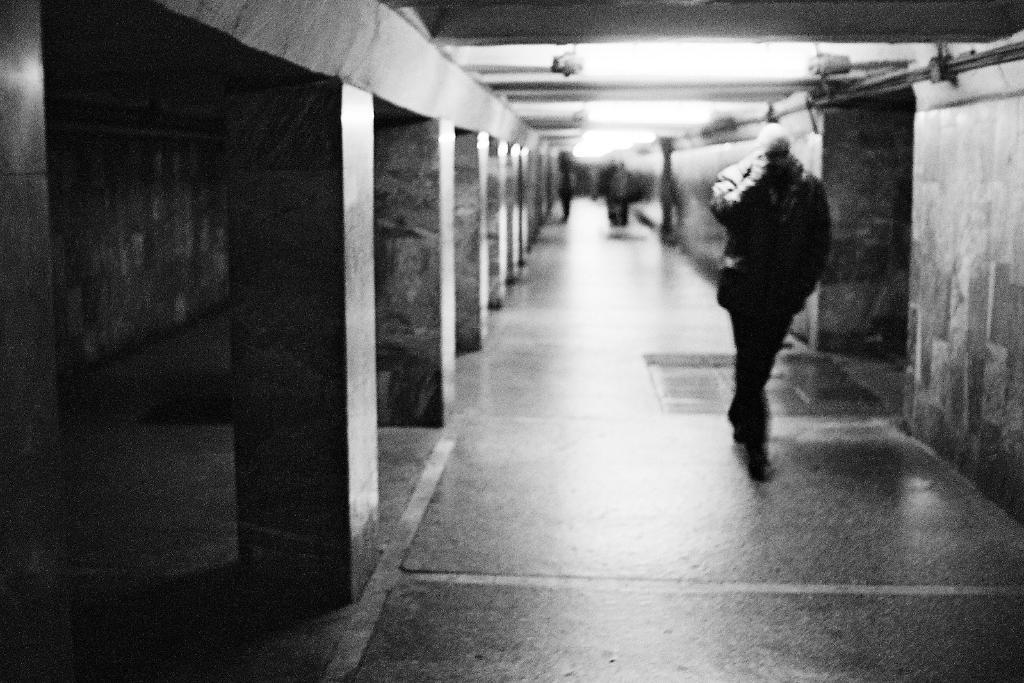Who or what can be seen in the image? There are people in the image. What architectural features are present in the image? There are pillars in the image. What is visible in the background of the image? There is a wall in the background of the image. What can be seen at the top of the image? There are lights at the top of the image. What type of eggnog is being served by the carpenter in the image? There is no carpenter or eggnog present in the image. Can you tell me if there is any blood visible in the image? There is no blood visible in the image. 